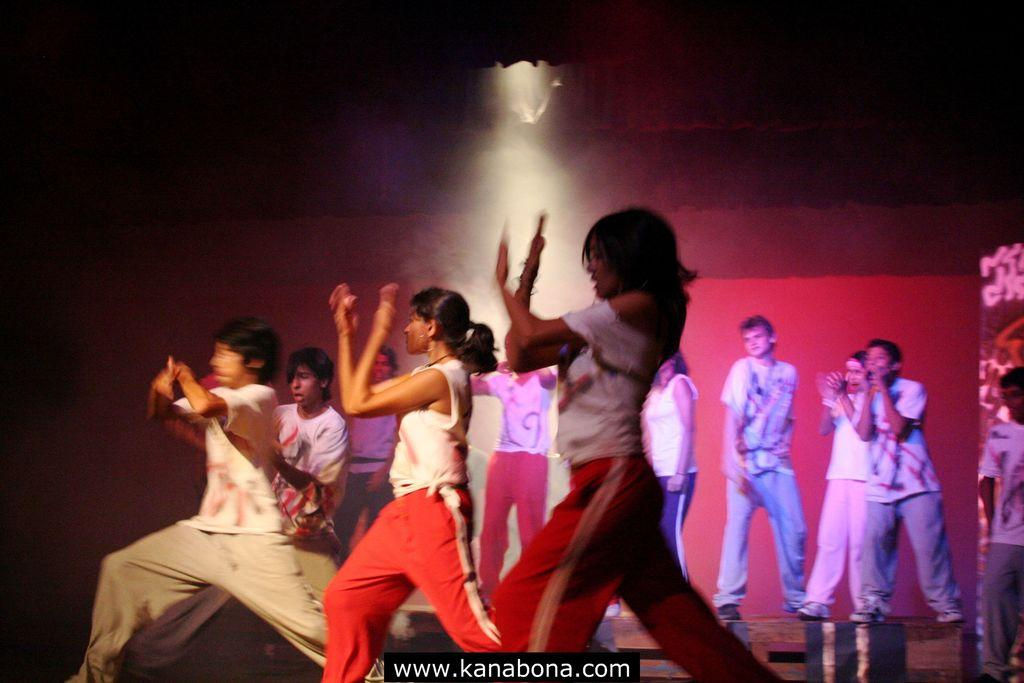What are the people in the image wearing? The people in the image are wearing different color dresses. What colors can be seen in the background of the image? The background of the image is in red and black colors. Can you describe the lighting in the image? Yes, there is visible lighting in the image. What type of match is being played in the image? There is no match being played in the image; it does not depict any sports or games. 